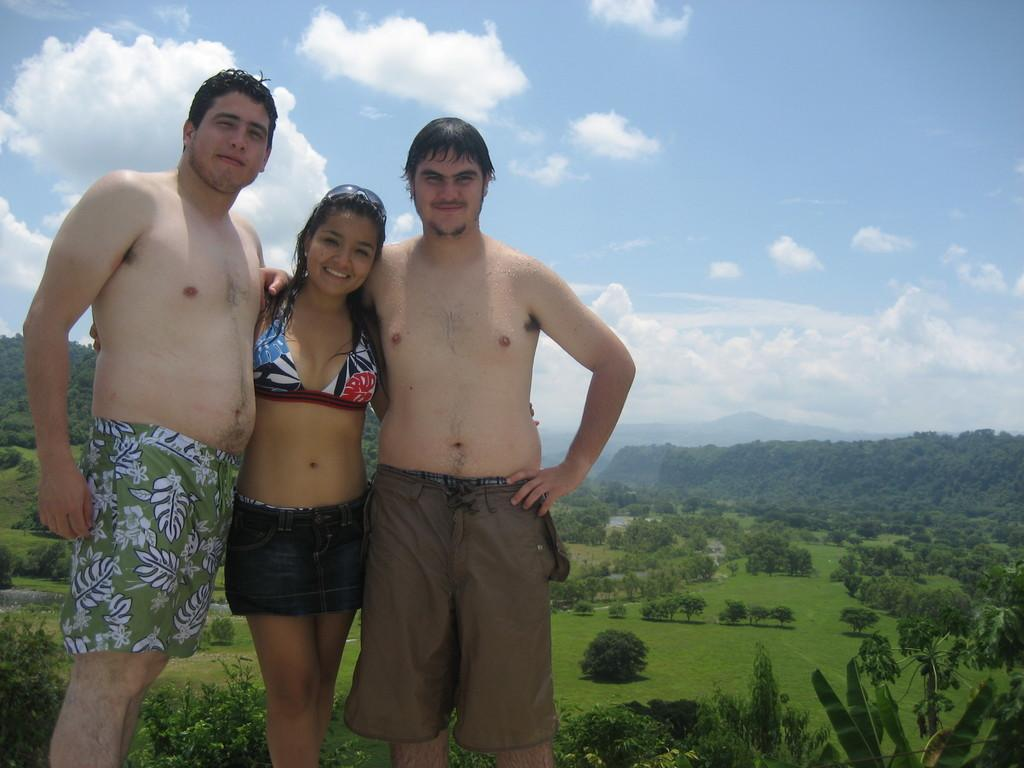How many people are in the image? There are three people in the image: one lady and two men. What are the people in the image doing? The lady and men are standing. What can be seen in the background of the image? There are trees, a mountain, and the sky visible in the background of the image. What type of education is the lady pursuing in the image? There is no indication of the lady pursuing any education in the image. What support system is visible for the men in the image? There is no visible support system for the men in the image. 